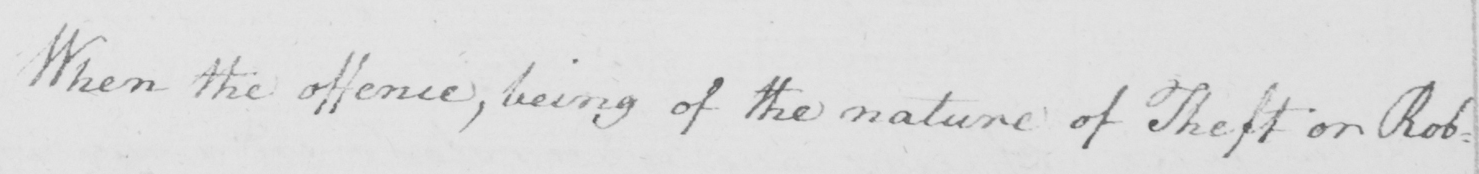What is written in this line of handwriting? When the offence  , being of the nature of Theft or Rob= 